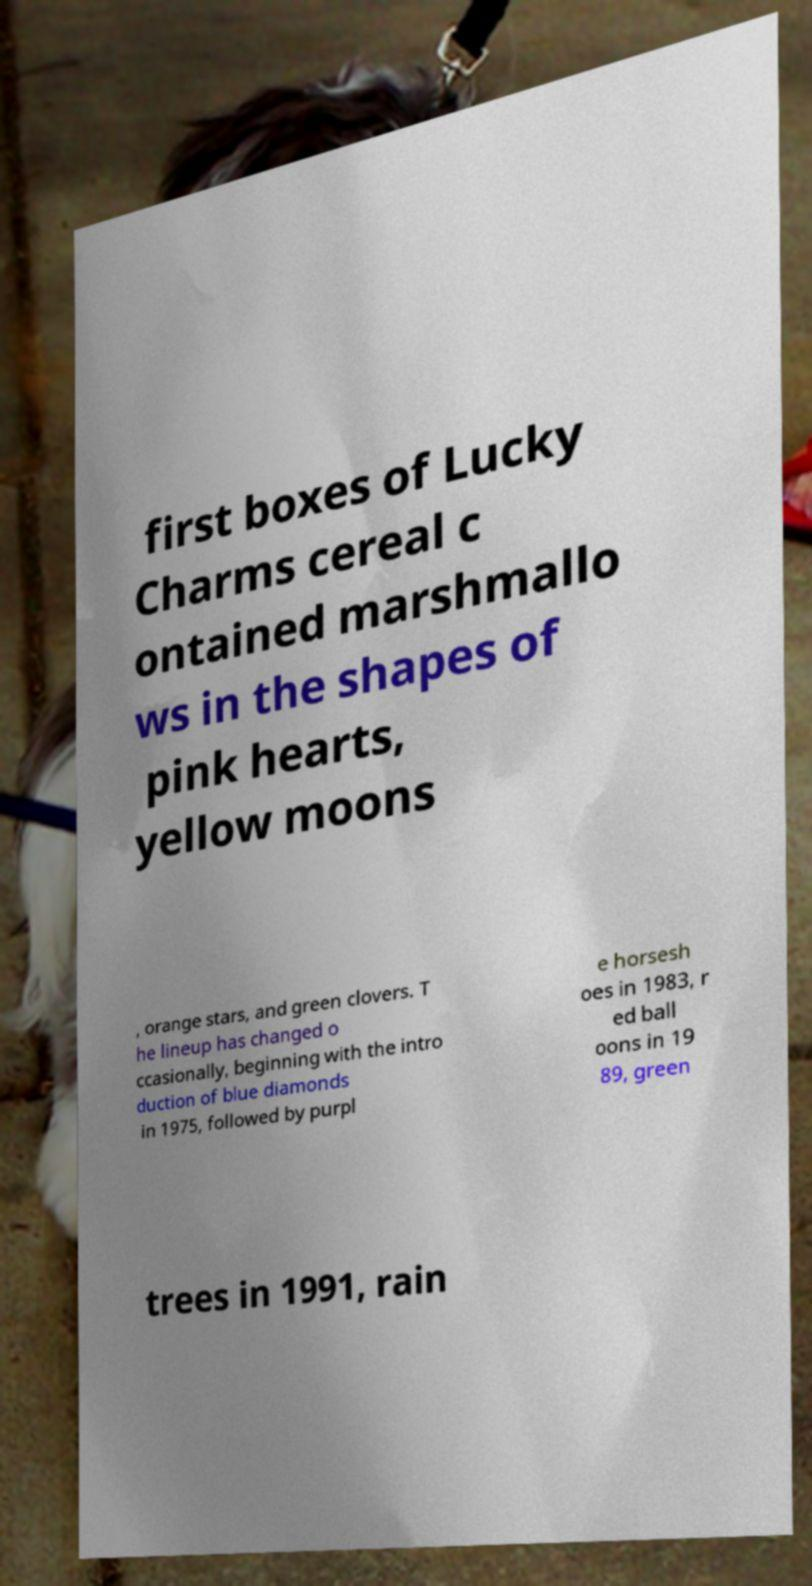There's text embedded in this image that I need extracted. Can you transcribe it verbatim? first boxes of Lucky Charms cereal c ontained marshmallo ws in the shapes of pink hearts, yellow moons , orange stars, and green clovers. T he lineup has changed o ccasionally, beginning with the intro duction of blue diamonds in 1975, followed by purpl e horsesh oes in 1983, r ed ball oons in 19 89, green trees in 1991, rain 